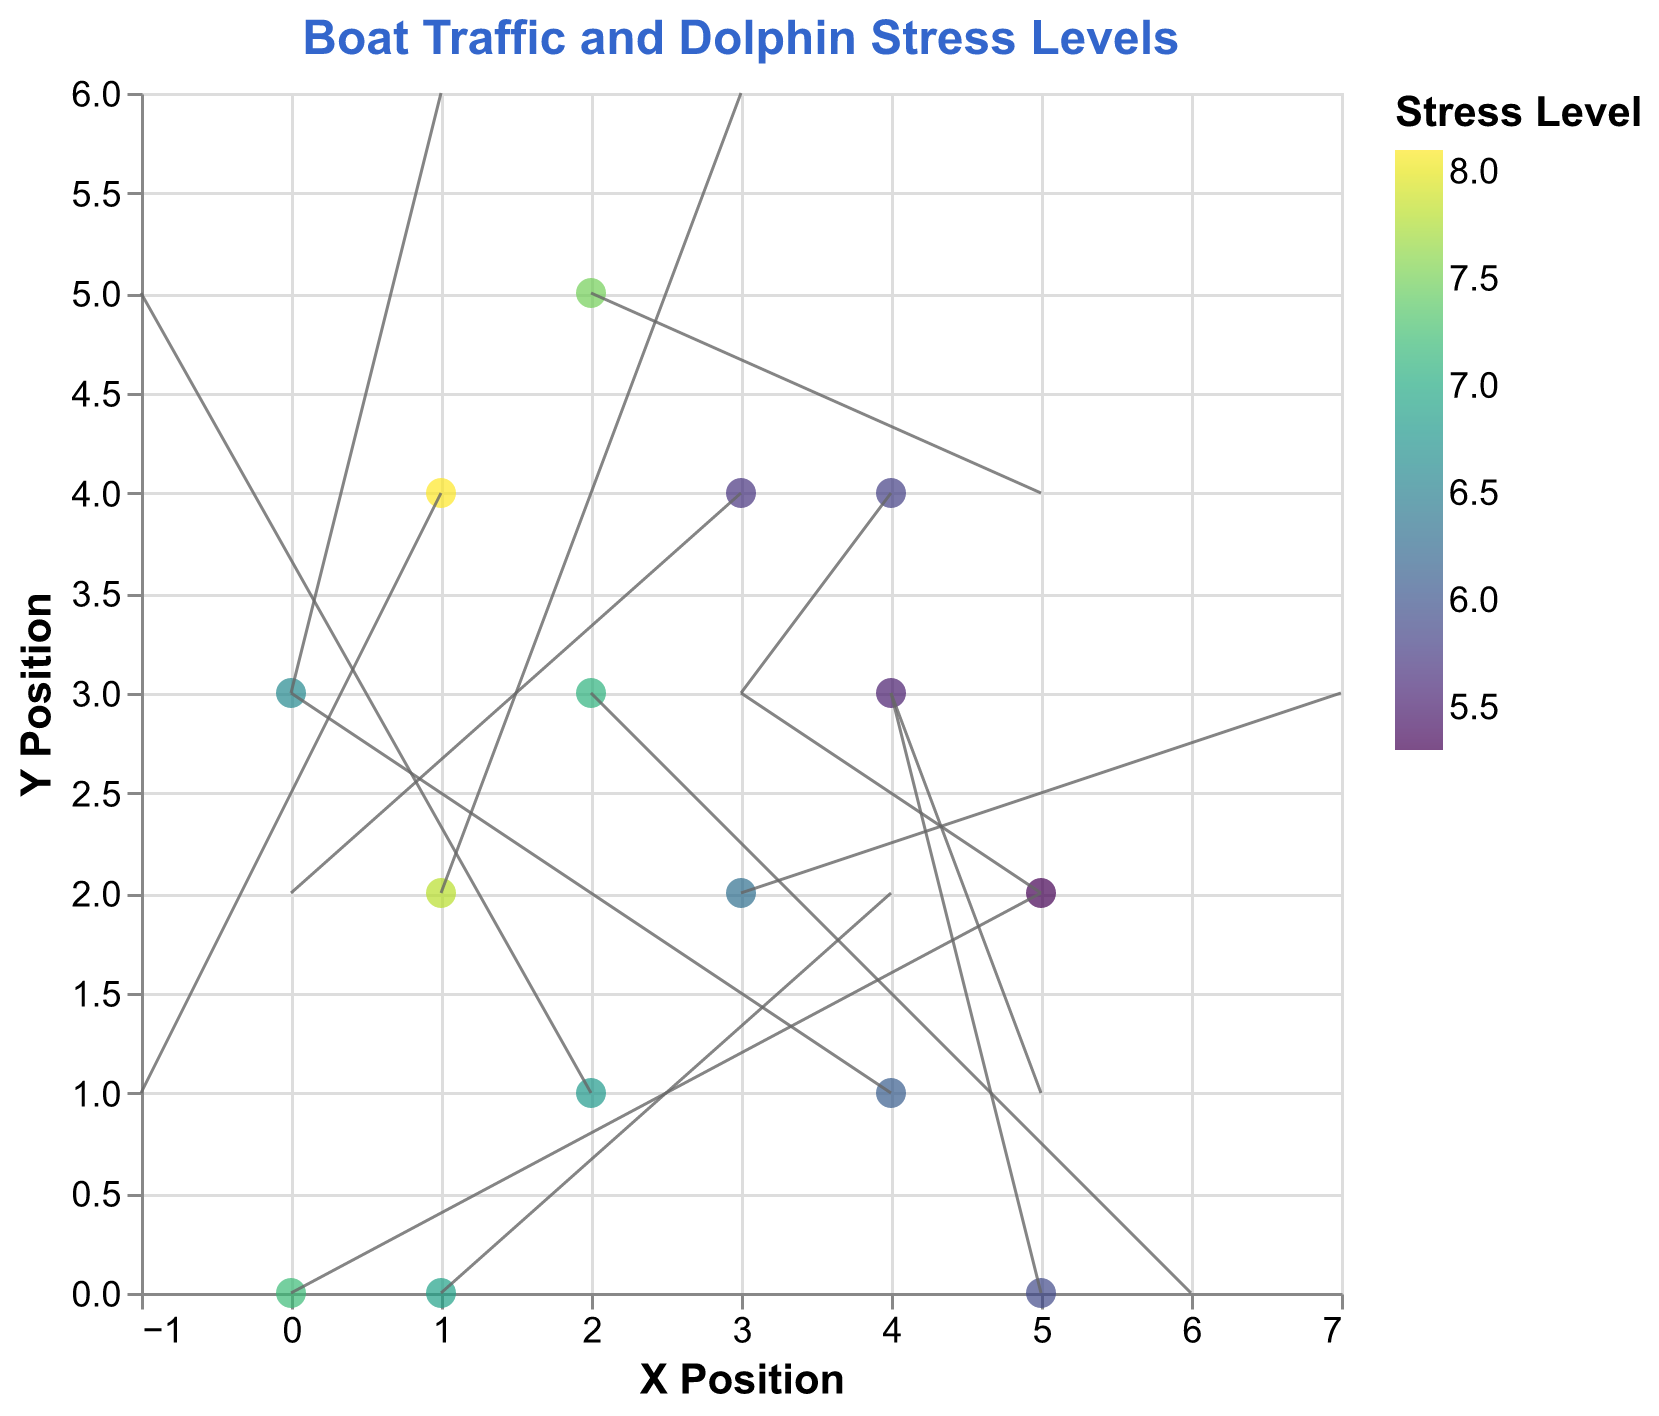How many data points are shown in the plot? There are 15 rows of data provided, each representing a data point in the plot.
Answer: 15 Which data point has the highest stress level? By looking at the color scale and the data points, the point at (1, 4) has the highest stress level of 8.1.
Answer: (1, 4) What is the direction and length of the vector at position (0, 0)? The vector at (0, 0) has components (u=5, v=2). The direction points positively along both x and y axes. The length can be calculated using the Pythagorean theorem: √(5^2 + 2^2) = √29 ≈ 5.39.
Answer: Direction: (5,2), Length: 5.39 Compare the stress levels of the data points at (1,4) and (4,3). Which one is higher? The stress level at (1, 4) is 8.1, while the stress level at (4, 3) is 5.5. 8.1 is higher than 5.5.
Answer: (1,4) What is the average stress level across all data points? Sum all the stress levels provided: 7.2 + 6.8 + 5.5 + 8.1 + 6.3 + 5.9 + 7.5 + 6.1 + 7.8 + 5.7 + 6.6 + 5.3 + 7.1 + 5.8 + 6.9. Then divide by the number of data points which is 15. The sum is 100.6, and 100.6 / 15 ≈ 6.71.
Answer: 6.71 Which vector has the greatest change in the y direction? By inspecting the values of v, the data point at location (1, 2) has the greatest value of v, which is 4.0, indicating the greatest change in the y direction.
Answer: (1, 2) Is there a general correlation between the vector direction and stress levels? The vectors do not appear to have a clear or consistent pattern when compared to the stress levels shown by the color gradient. Stress levels vary regardless of vector direction and length.
Answer: No clear correlation What is the direction of the vector at position (4, 1)? Does it show an increase or decrease in x? The vector at (4, 1) has components (u=-4, v=2). The negative u component indicates a decrease in x, while the positive v component indicates an increase in y.
Answer: Decrease in x, Increase in y Compare the stress levels at positions with an increase in x (positive u values). Is there a general pattern? Data points with positive u values and their stress levels: (0, 0): 7.2, (3, 2): 6.3, (1, 2): 7.8,  (2, 5): 7.5,  (2, 3): 7.1,  (1, 0): 6.9. The stress levels vary without a clear pattern.
Answer: No clear pattern 